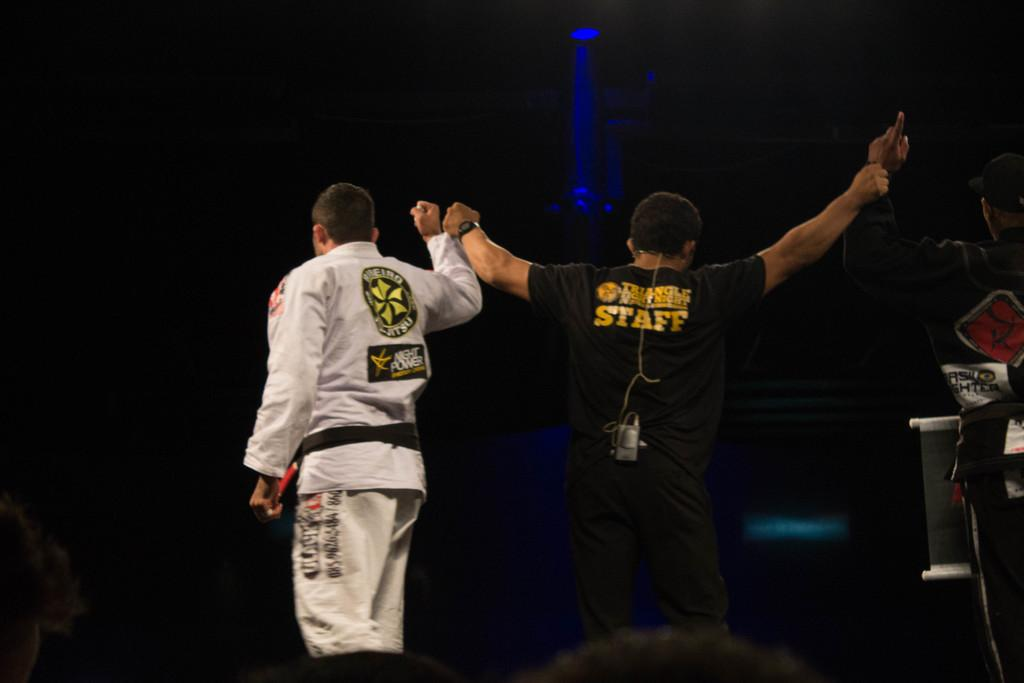<image>
Relay a brief, clear account of the picture shown. The man with the black shirt on has the word staff on his back. 